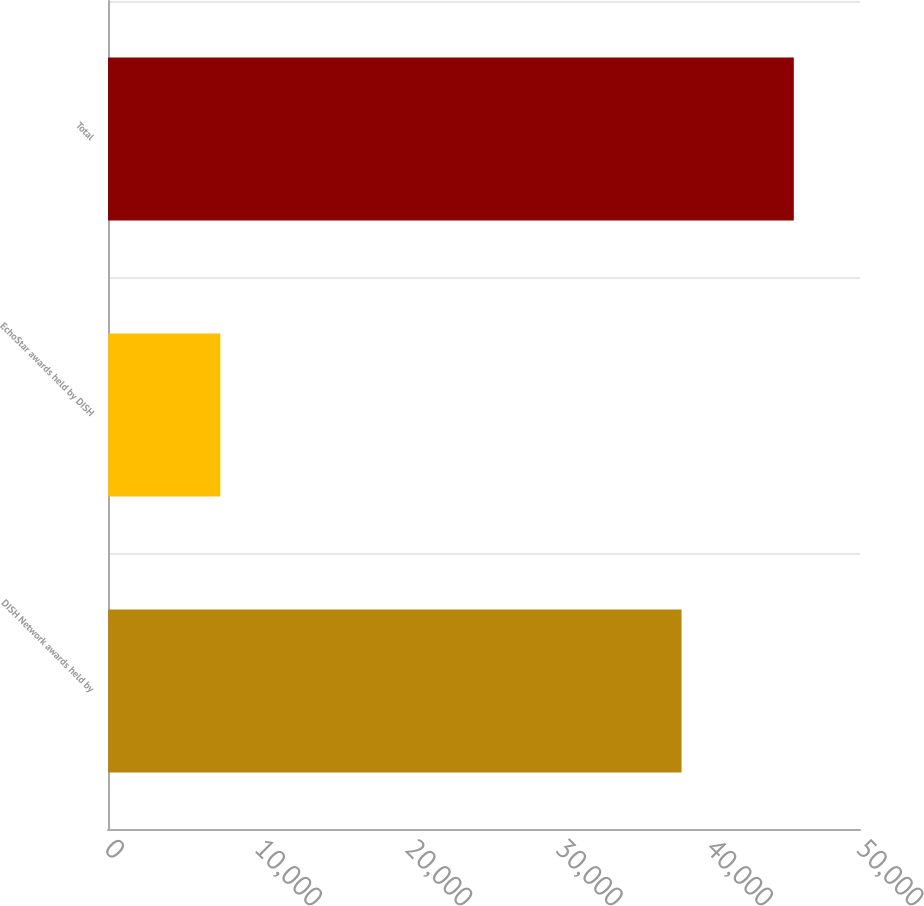Convert chart to OTSL. <chart><loc_0><loc_0><loc_500><loc_500><bar_chart><fcel>DISH Network awards held by<fcel>EchoStar awards held by DISH<fcel>Total<nl><fcel>38134<fcel>7466<fcel>45600<nl></chart> 